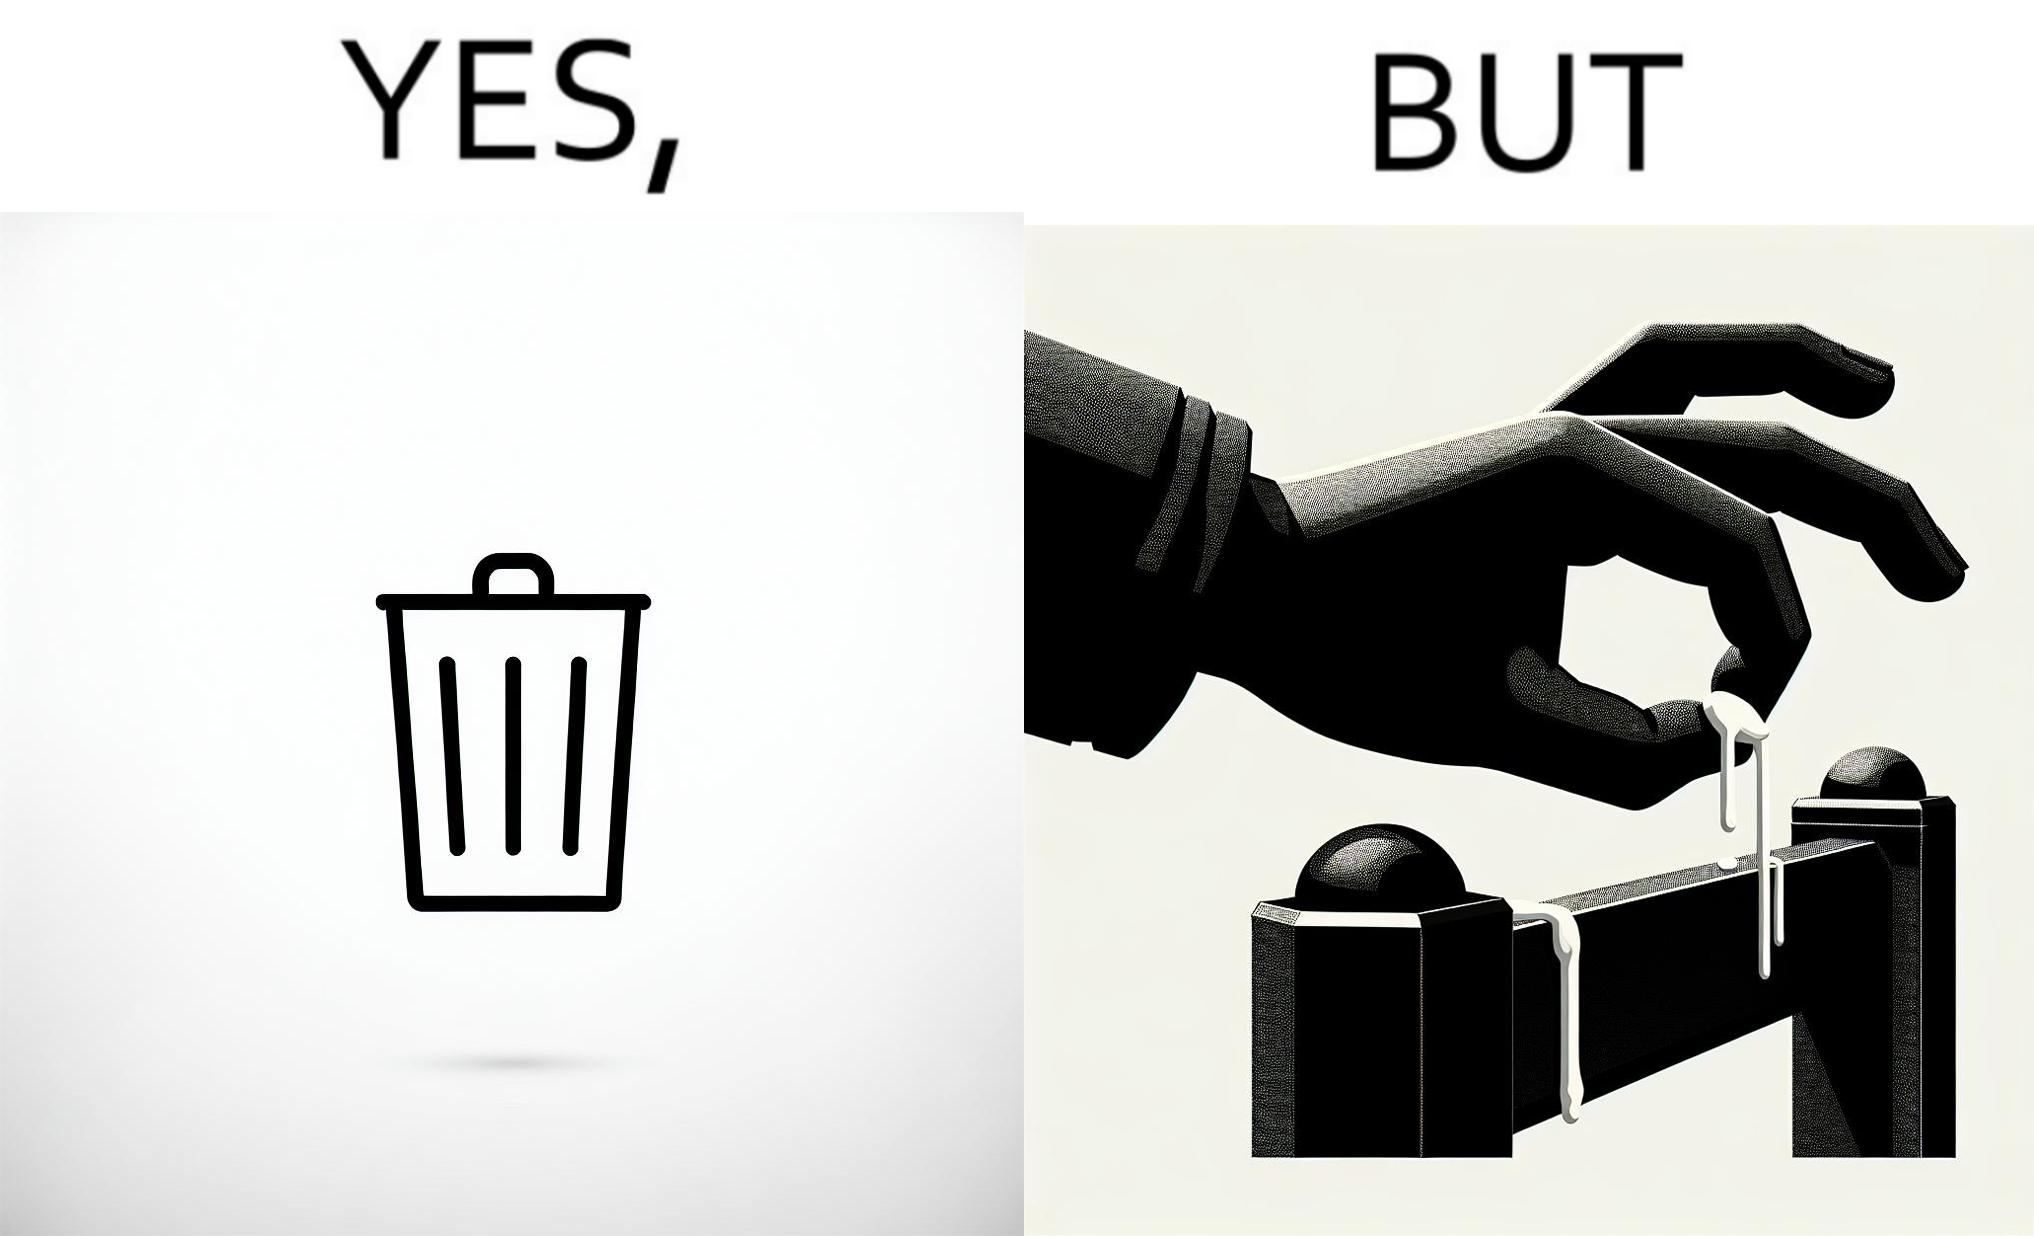What do you see in each half of this image? In the left part of the image: It is a garbage bin In the right part of the image: It is a human hand sticking chewing gum on public property 